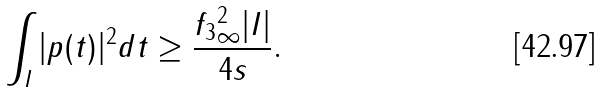Convert formula to latex. <formula><loc_0><loc_0><loc_500><loc_500>\int _ { I } | p ( t ) | ^ { 2 } d t \geq \frac { \| f _ { 3 } \| ^ { 2 } _ { \infty } | I | } { 4 s } .</formula> 